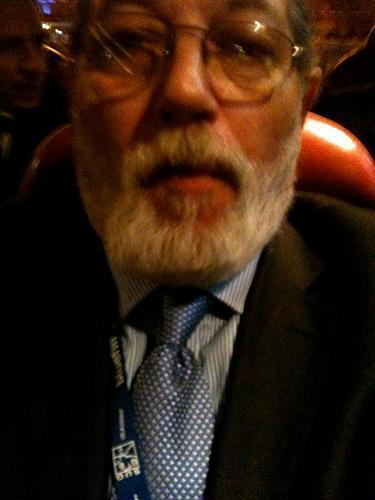The person wearing the blue tie looks most like whom?
Select the accurate answer and provide explanation: 'Answer: answer
Rationale: rationale.'
Options: Idris elba, liv morgan, donald pleasence, keith david. Answer: donald pleasence.
Rationale: The person looks like donald pleasance. 